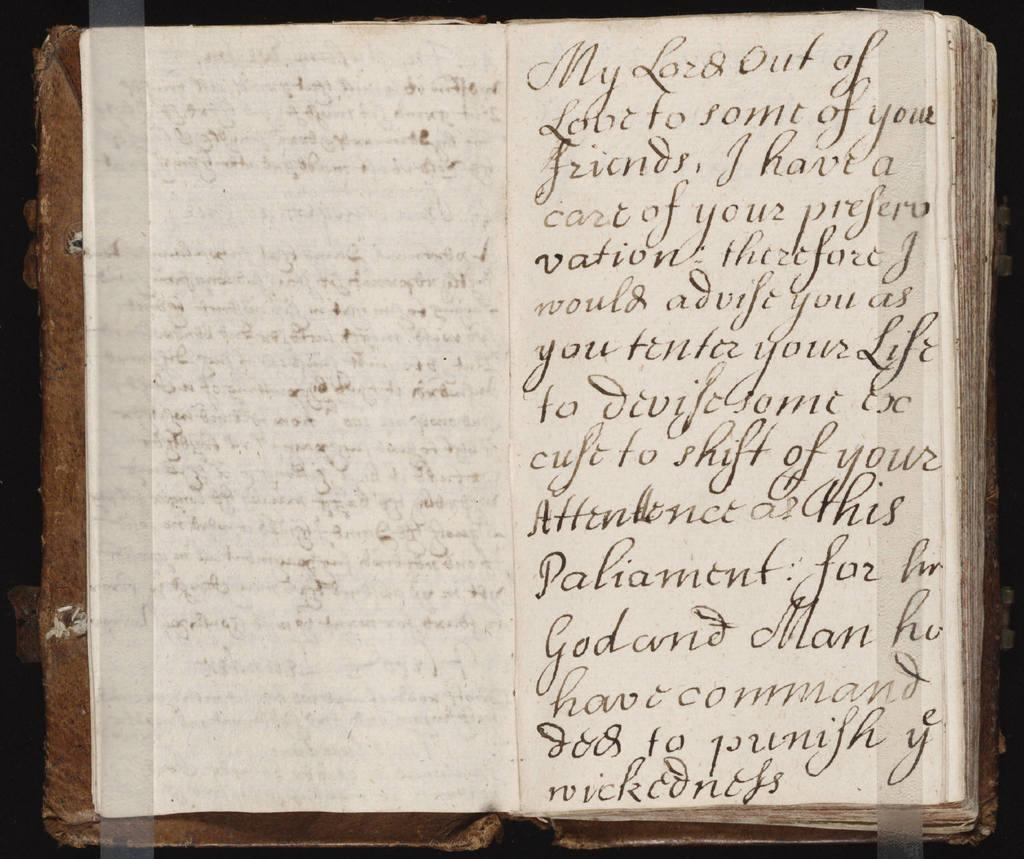<image>
Relay a brief, clear account of the picture shown. the page on the right hand side of the opened book has the first word My 